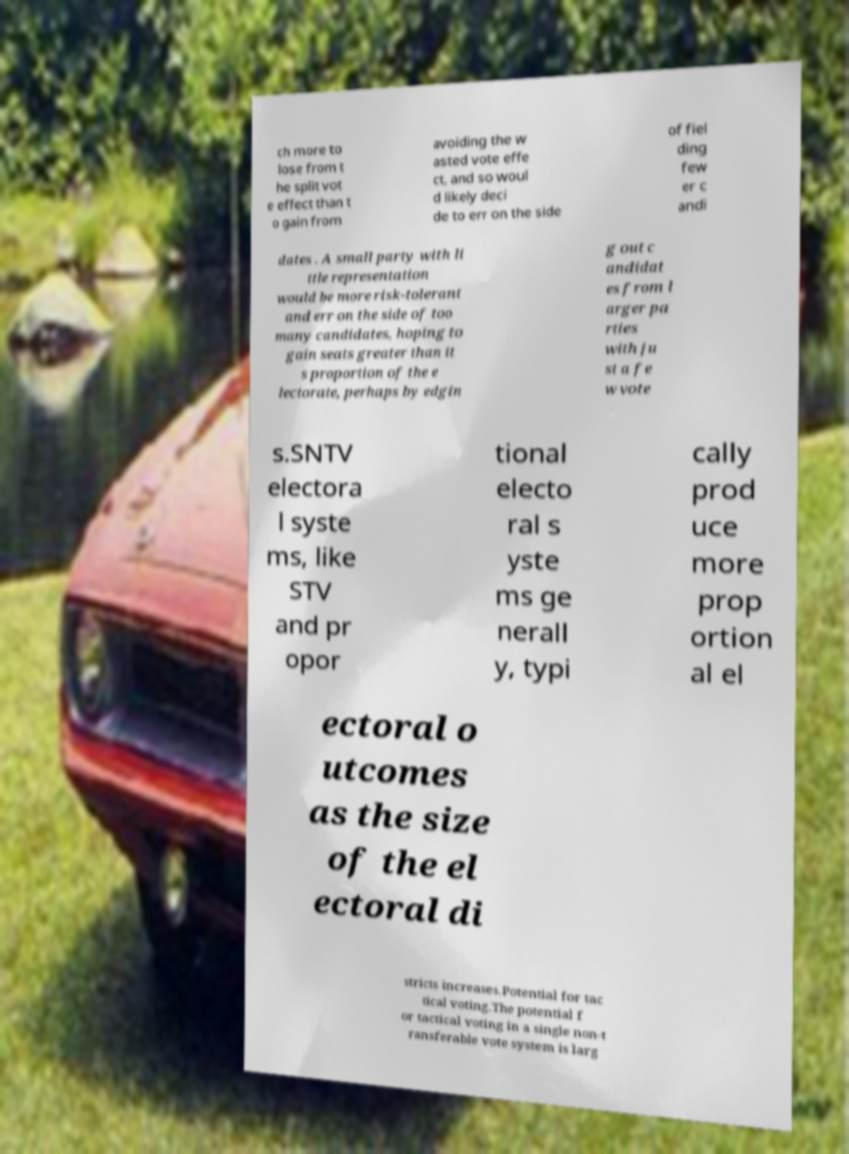Please read and relay the text visible in this image. What does it say? ch more to lose from t he split vot e effect than t o gain from avoiding the w asted vote effe ct, and so woul d likely deci de to err on the side of fiel ding few er c andi dates . A small party with li ttle representation would be more risk-tolerant and err on the side of too many candidates, hoping to gain seats greater than it s proportion of the e lectorate, perhaps by edgin g out c andidat es from l arger pa rties with ju st a fe w vote s.SNTV electora l syste ms, like STV and pr opor tional electo ral s yste ms ge nerall y, typi cally prod uce more prop ortion al el ectoral o utcomes as the size of the el ectoral di stricts increases.Potential for tac tical voting.The potential f or tactical voting in a single non-t ransferable vote system is larg 